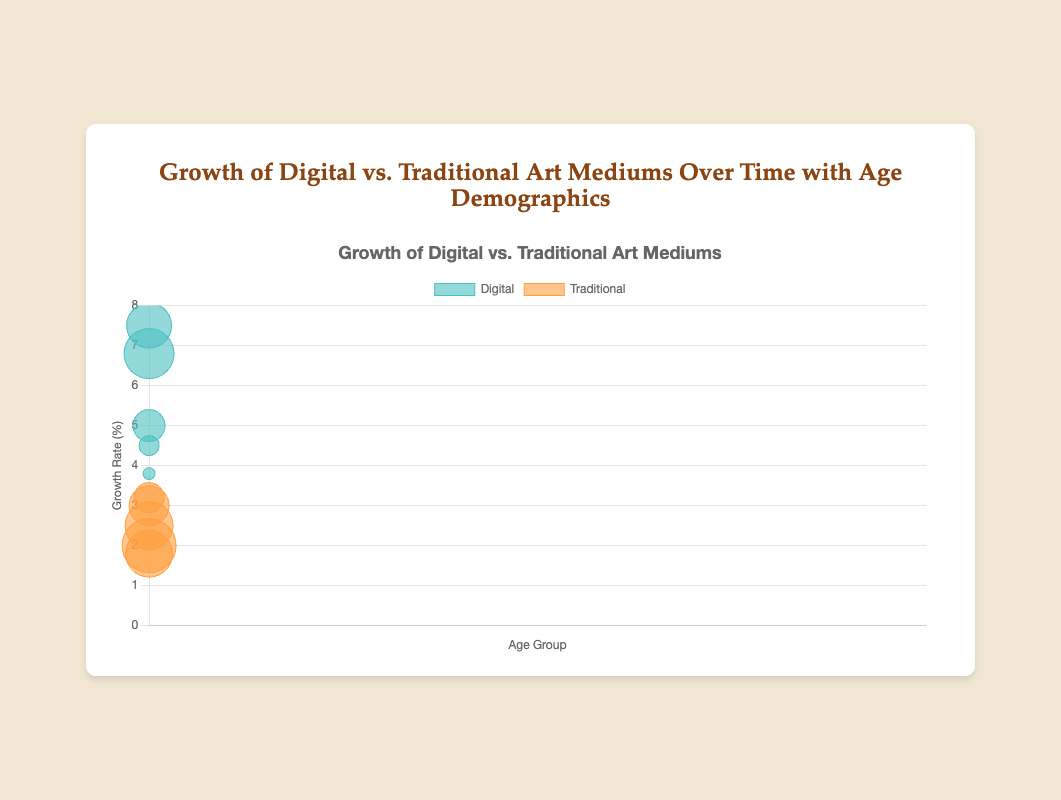What is the title of the chart? The header above the chart reads "Growth of Digital vs. Traditional Art Mediums Over Time with Age Demographics"
Answer: Growth of Digital vs. Traditional Art Mediums Over Time with Age Demographics What are the labels for the x and y axes? The labels for the axes can be seen near the respective axes. The x-axis is labeled "Age Group," and the y-axis is labeled "Growth Rate (%)"
Answer: Age Group, Growth Rate (%) Which age group has the highest number of digital artists represented in the chart? From the size of the bubbles in the digital medium dataset, the largest bubble corresponds to the age group "26-35" with 500 artists
Answer: 26-35 In the 36-45 age group, which medium shows a higher growth rate? By comparing the y-axis position for both bubbles in the 36-45 age group, the digital medium shows a growth rate of 5.0%, while the traditional medium shows 2.5%
Answer: Digital How does the growth rate of digital art for the 18-25 age group compare to that of traditional art? The digital art growth rate for the 18-25 age group is 7.5%, while the traditional art growth rate is 3.2%. By visual comparison, digital art has a significantly higher growth rate in this age group
Answer: Digital is higher Which traditional art group has the smallest growth rate, and what is that rate? Observing the traditional medium datasets, the smallest y-value occurs in the 56-65 age group with a growth rate of 1.8%
Answer: 56-65, 1.8% What is the combined number of artists in the 46-55 age group for both mediums? The number of artists for the digital medium is 200, and for the traditional medium, it is 540. Summing these values: 200 + 540 = 740
Answer: 740 What is the average growth rate for digital mediums across all age groups? The growth rates for digital mediums are: 7.5%, 6.8%, 5.0%, 4.5%, and 3.8%. Adding them: 7.5 + 6.8 + 5.0 + 4.5 + 3.8 = 27.6. Dividing by the number of groups (5): 27.6 / 5 = 5.52
Answer: 5.52% How many data points represent the traditional medium? Each age group has one data point for each medium, and there are 5 age groups, resulting in 5 data points for the traditional medium
Answer: 5 Which medium shows a more consistent growth rate across the age groups? Comparing the vertical spread of bubbles, traditional mediums have a smaller range between growth rates (1.8% to 3.2%) compared to digital mediums (3.8% to 7.5%). The traditional medium shows a more consistent growth rate
Answer: Traditional 